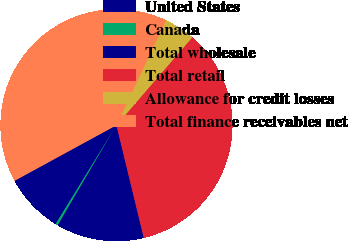<chart> <loc_0><loc_0><loc_500><loc_500><pie_chart><fcel>United States<fcel>Canada<fcel>Total wholesale<fcel>Total retail<fcel>Allowance for credit losses<fcel>Total finance receivables net<nl><fcel>8.27%<fcel>0.34%<fcel>12.23%<fcel>34.88%<fcel>4.3%<fcel>39.98%<nl></chart> 